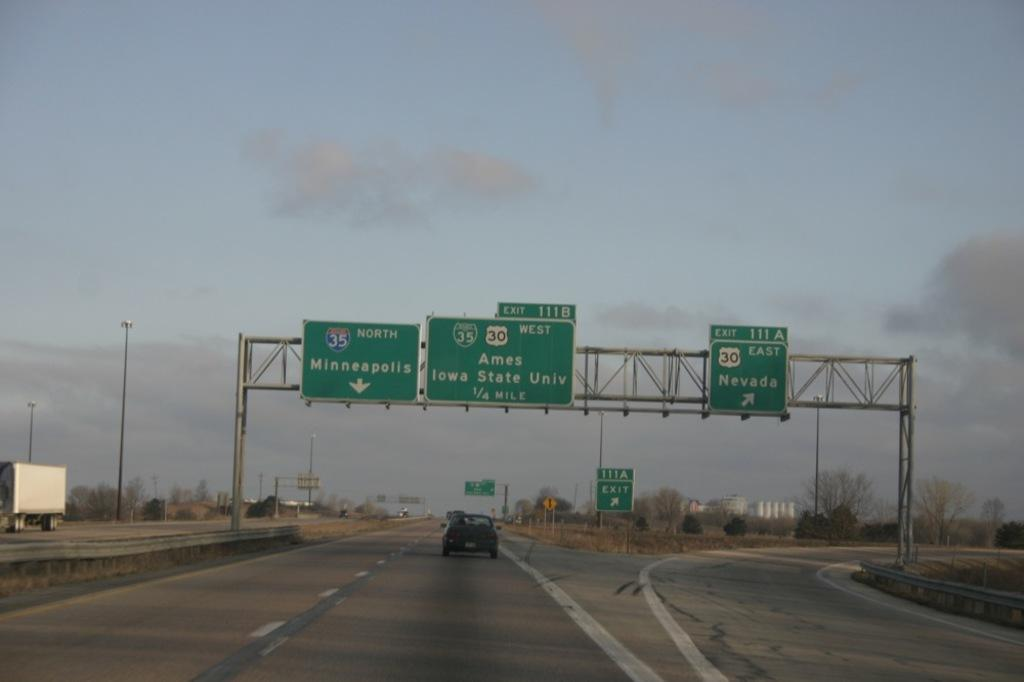<image>
Create a compact narrative representing the image presented. A freeway going through an area with destination signs for Ames Iowa State University and Nevada and Minneapolis 